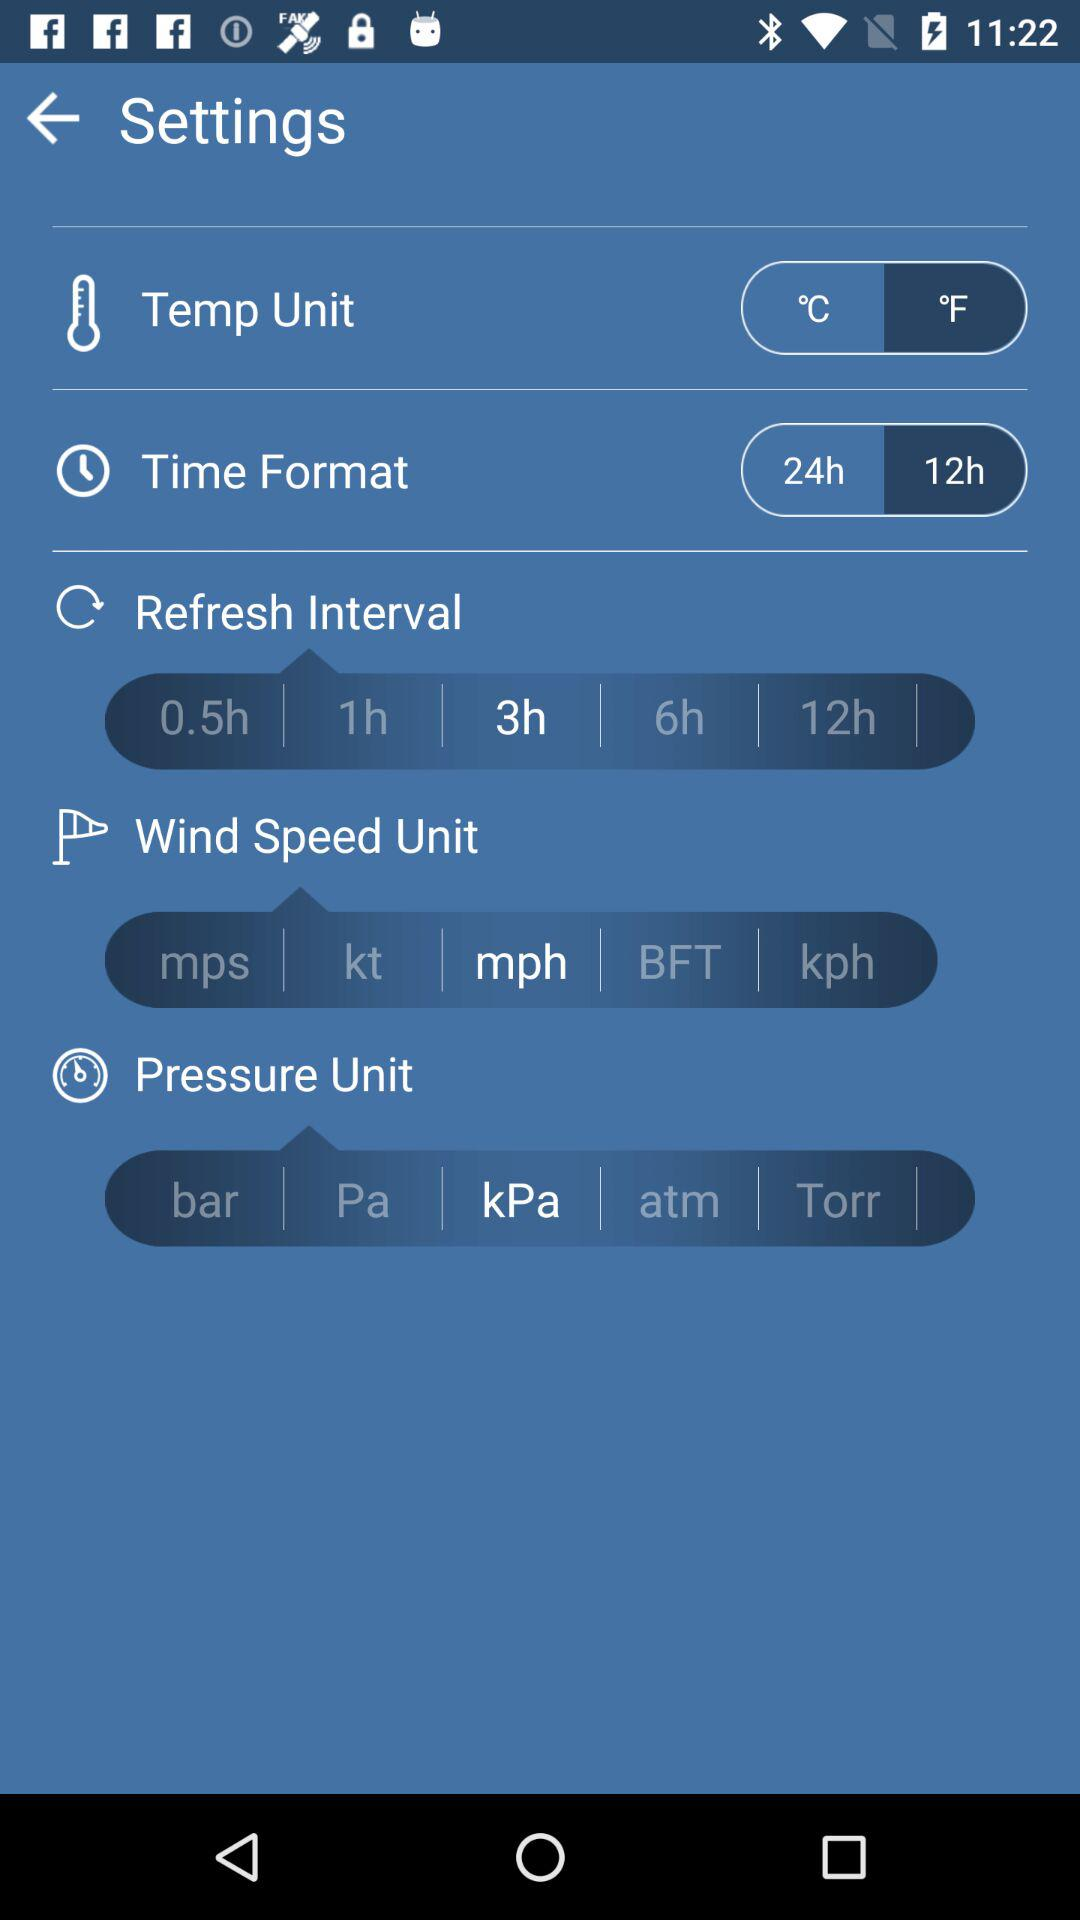How many units does the pressure section have?
Answer the question using a single word or phrase. 5 